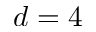Convert formula to latex. <formula><loc_0><loc_0><loc_500><loc_500>d = 4</formula> 